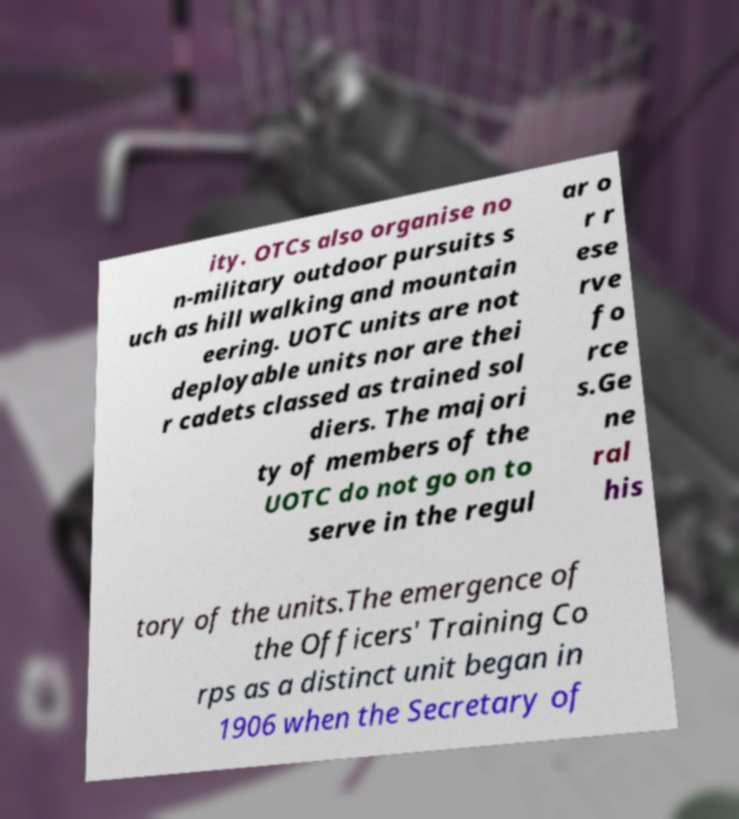Can you accurately transcribe the text from the provided image for me? ity. OTCs also organise no n-military outdoor pursuits s uch as hill walking and mountain eering. UOTC units are not deployable units nor are thei r cadets classed as trained sol diers. The majori ty of members of the UOTC do not go on to serve in the regul ar o r r ese rve fo rce s.Ge ne ral his tory of the units.The emergence of the Officers' Training Co rps as a distinct unit began in 1906 when the Secretary of 